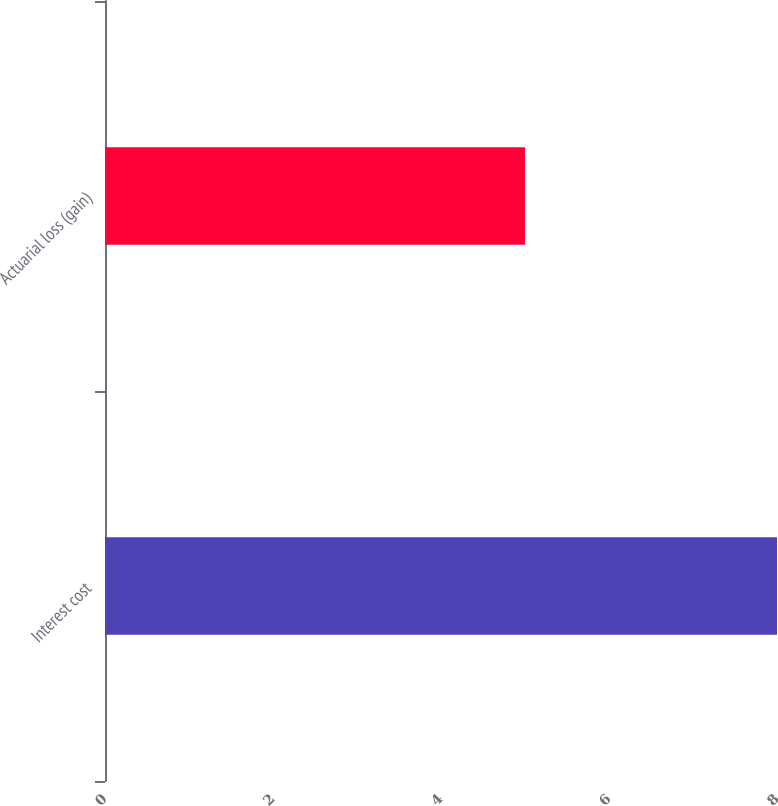<chart> <loc_0><loc_0><loc_500><loc_500><bar_chart><fcel>Interest cost<fcel>Actuarial loss (gain)<nl><fcel>8<fcel>5<nl></chart> 